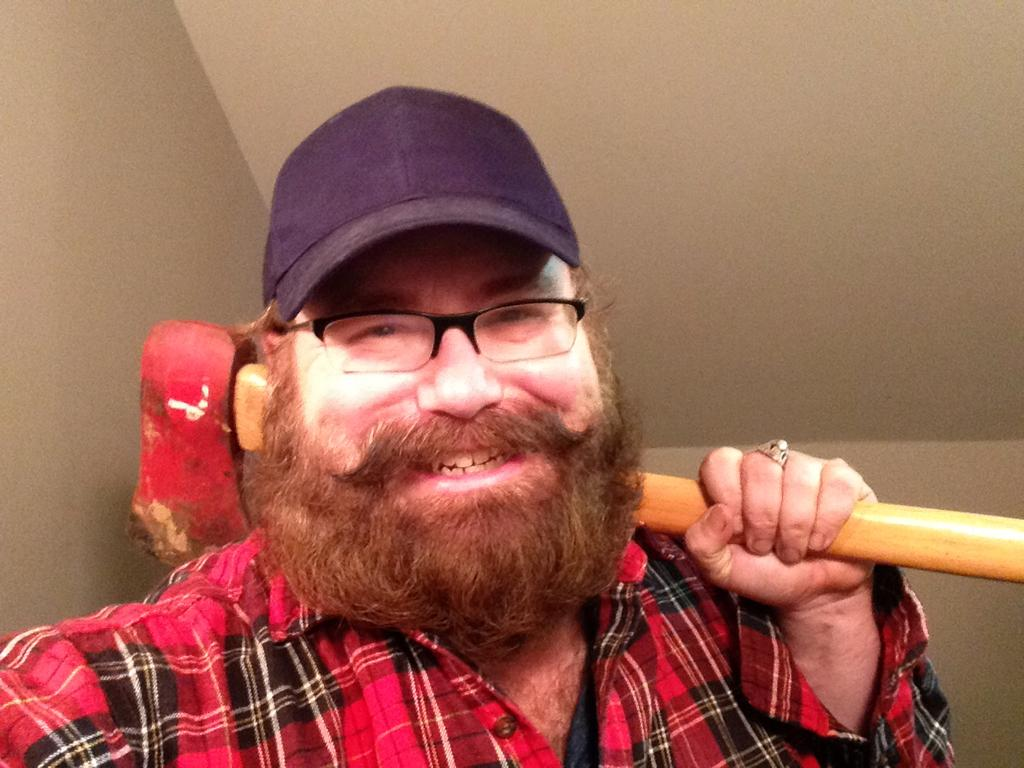What is the main subject of the image? There is a person in the image. What is the person wearing on their upper body? The person is wearing a red shirt. What type of headwear is the person wearing? The person is wearing a hat. What tool is the person holding in the image? The person is holding a hammer. What can be seen in the background of the image? There is a wall in the background of the image. What color is the wall in the image? The wall is painted white. What type of bait is the person using to catch fish in the image? There is no indication of fishing or bait in the image; the person is holding a hammer and standing near a wall. 